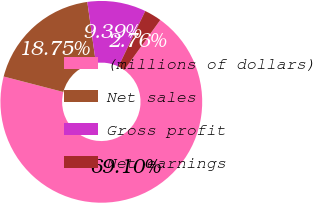Convert chart to OTSL. <chart><loc_0><loc_0><loc_500><loc_500><pie_chart><fcel>(millions of dollars)<fcel>Net sales<fcel>Gross profit<fcel>Net earnings<nl><fcel>69.11%<fcel>18.75%<fcel>9.39%<fcel>2.76%<nl></chart> 